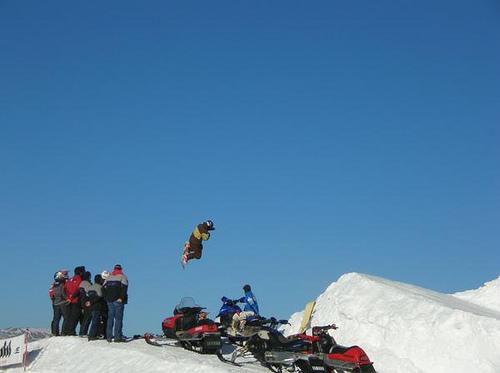What is the man flying over the house using on his feet?
Be succinct. Snowboard. How many skis is the man riding?
Keep it brief. 2. What is standing next to the man?
Short answer required. Snowmobile. What season is it?
Be succinct. Winter. Are the vehicles for snow?
Answer briefly. Yes. Is the person airborne in the image wearing skis?
Be succinct. No. 